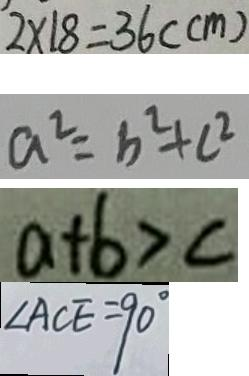Convert formula to latex. <formula><loc_0><loc_0><loc_500><loc_500>2 \times 1 8 = 3 6 ( c m ) 
 a ^ { 2 } = b ^ { 2 } + c ^ { 2 } 
 a + b > c 
 \angle A C E = 9 0 ^ { \circ }</formula> 